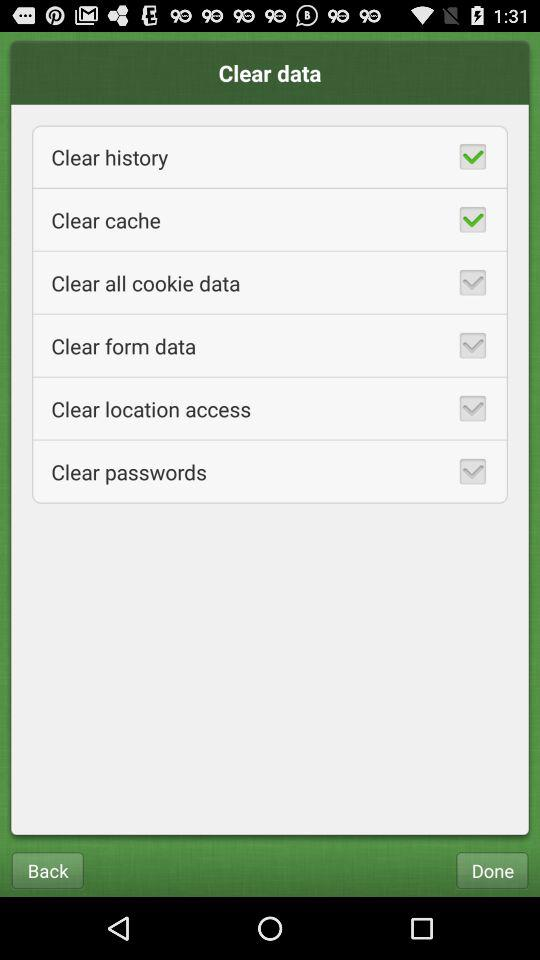How many data items can be cleared?
Answer the question using a single word or phrase. 6 